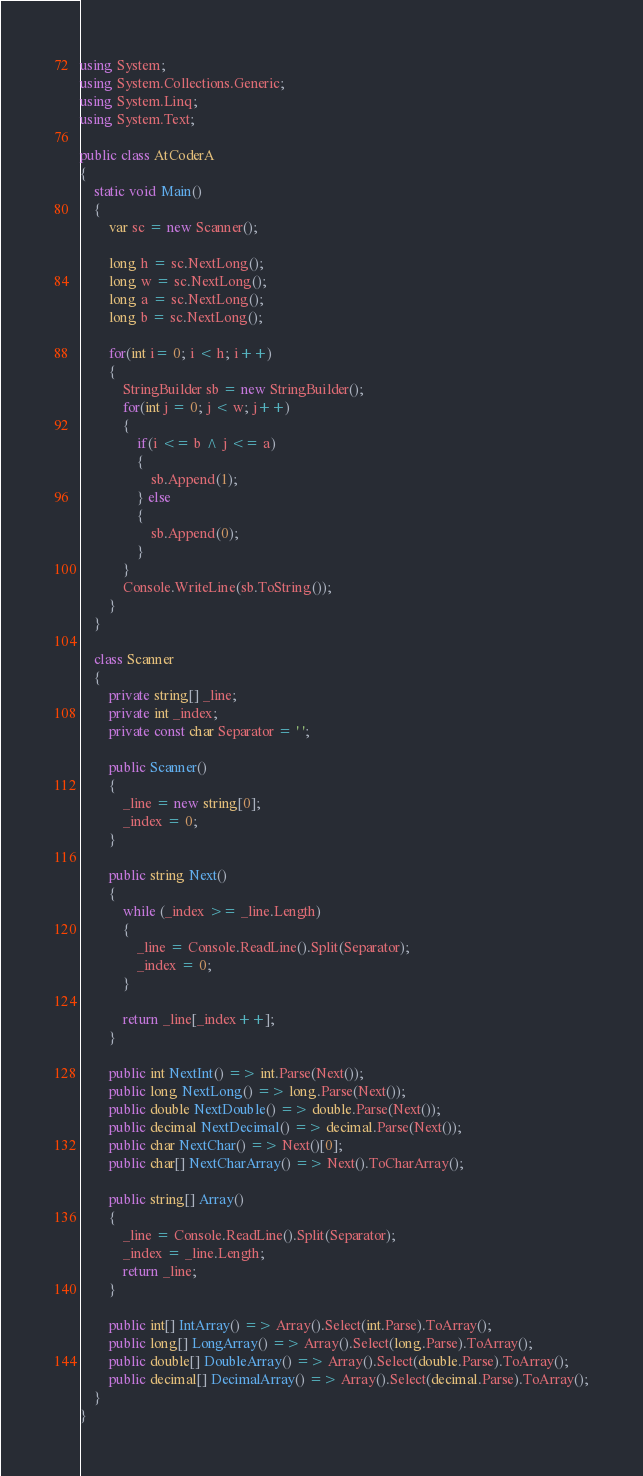<code> <loc_0><loc_0><loc_500><loc_500><_C#_>using System;
using System.Collections.Generic;
using System.Linq;
using System.Text;

public class AtCoderA
{
    static void Main()
    {
        var sc = new Scanner();

        long h = sc.NextLong();
        long w = sc.NextLong();
        long a = sc.NextLong();
        long b = sc.NextLong();

        for(int i= 0; i < h; i++)
        {
            StringBuilder sb = new StringBuilder();
            for(int j = 0; j < w; j++)
            {
                if(i <= b ^ j <= a)
                {
                    sb.Append(1);
                } else
                {
                    sb.Append(0);
                }
            }
            Console.WriteLine(sb.ToString());
        }
    }

    class Scanner
    {
        private string[] _line;
        private int _index;
        private const char Separator = ' ';

        public Scanner()
        {
            _line = new string[0];
            _index = 0;
        }

        public string Next()
        {
            while (_index >= _line.Length)
            {
                _line = Console.ReadLine().Split(Separator);
                _index = 0;
            }

            return _line[_index++];
        }

        public int NextInt() => int.Parse(Next());
        public long NextLong() => long.Parse(Next());
        public double NextDouble() => double.Parse(Next());
        public decimal NextDecimal() => decimal.Parse(Next());
        public char NextChar() => Next()[0];
        public char[] NextCharArray() => Next().ToCharArray();

        public string[] Array()
        {
            _line = Console.ReadLine().Split(Separator);
            _index = _line.Length;
            return _line;
        }

        public int[] IntArray() => Array().Select(int.Parse).ToArray();
        public long[] LongArray() => Array().Select(long.Parse).ToArray();
        public double[] DoubleArray() => Array().Select(double.Parse).ToArray();
        public decimal[] DecimalArray() => Array().Select(decimal.Parse).ToArray();
    }
}
</code> 